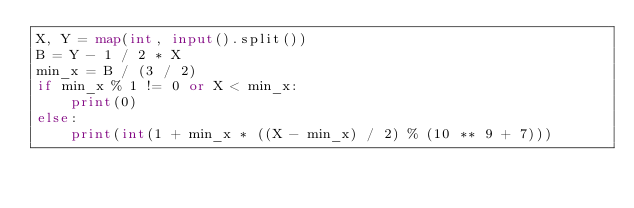Convert code to text. <code><loc_0><loc_0><loc_500><loc_500><_Python_>X, Y = map(int, input().split())
B = Y - 1 / 2 * X
min_x = B / (3 / 2)
if min_x % 1 != 0 or X < min_x:
    print(0)
else:
    print(int(1 + min_x * ((X - min_x) / 2) % (10 ** 9 + 7)))
</code> 